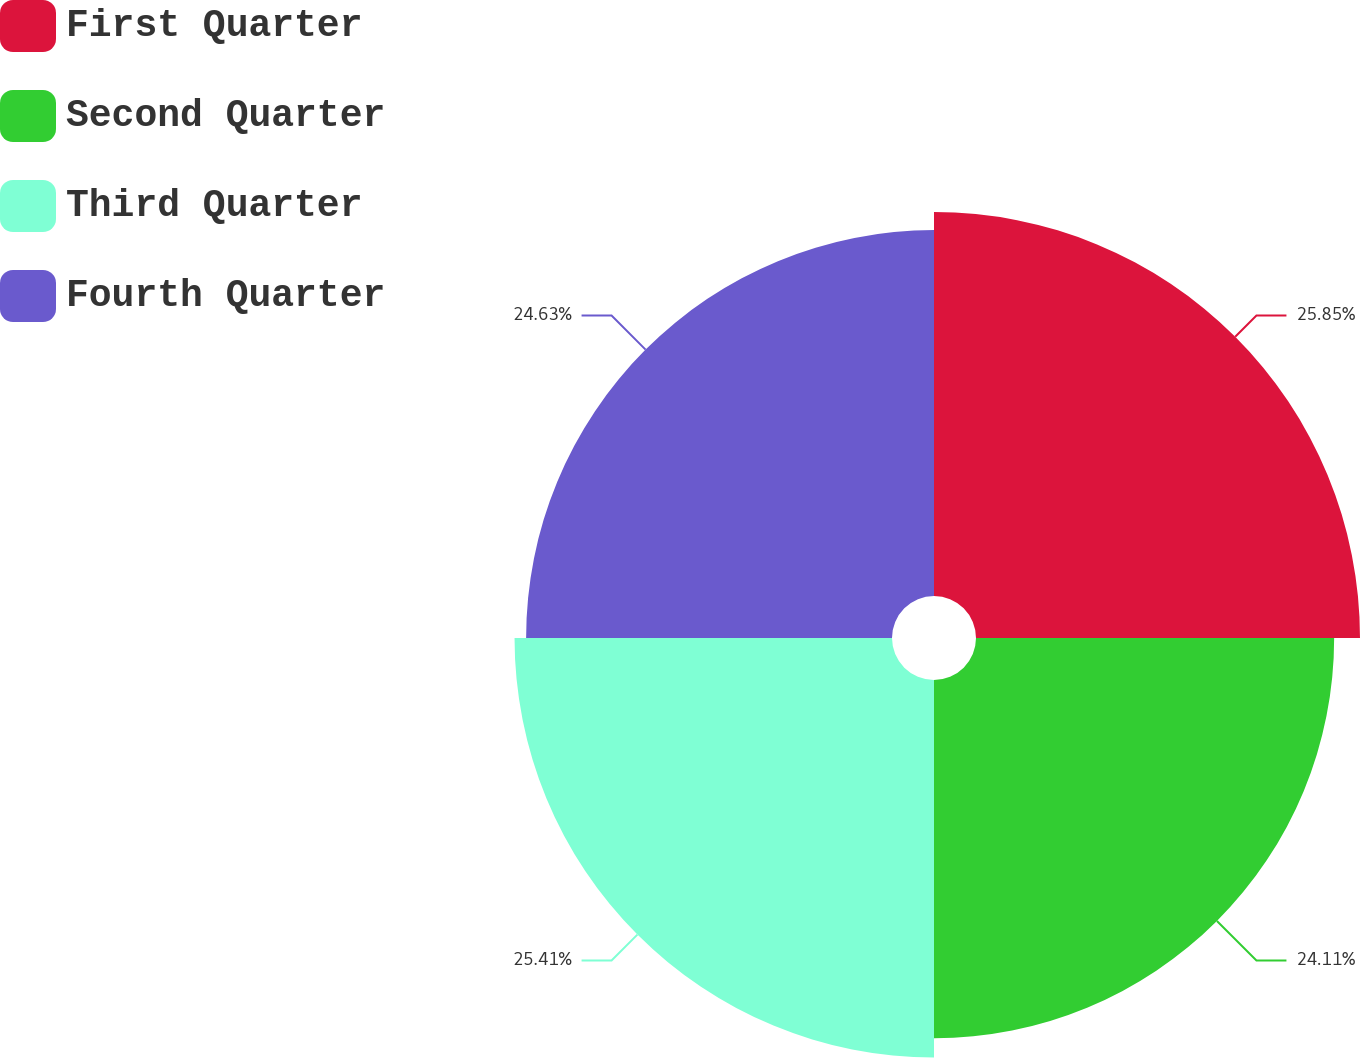Convert chart. <chart><loc_0><loc_0><loc_500><loc_500><pie_chart><fcel>First Quarter<fcel>Second Quarter<fcel>Third Quarter<fcel>Fourth Quarter<nl><fcel>25.85%<fcel>24.11%<fcel>25.41%<fcel>24.63%<nl></chart> 